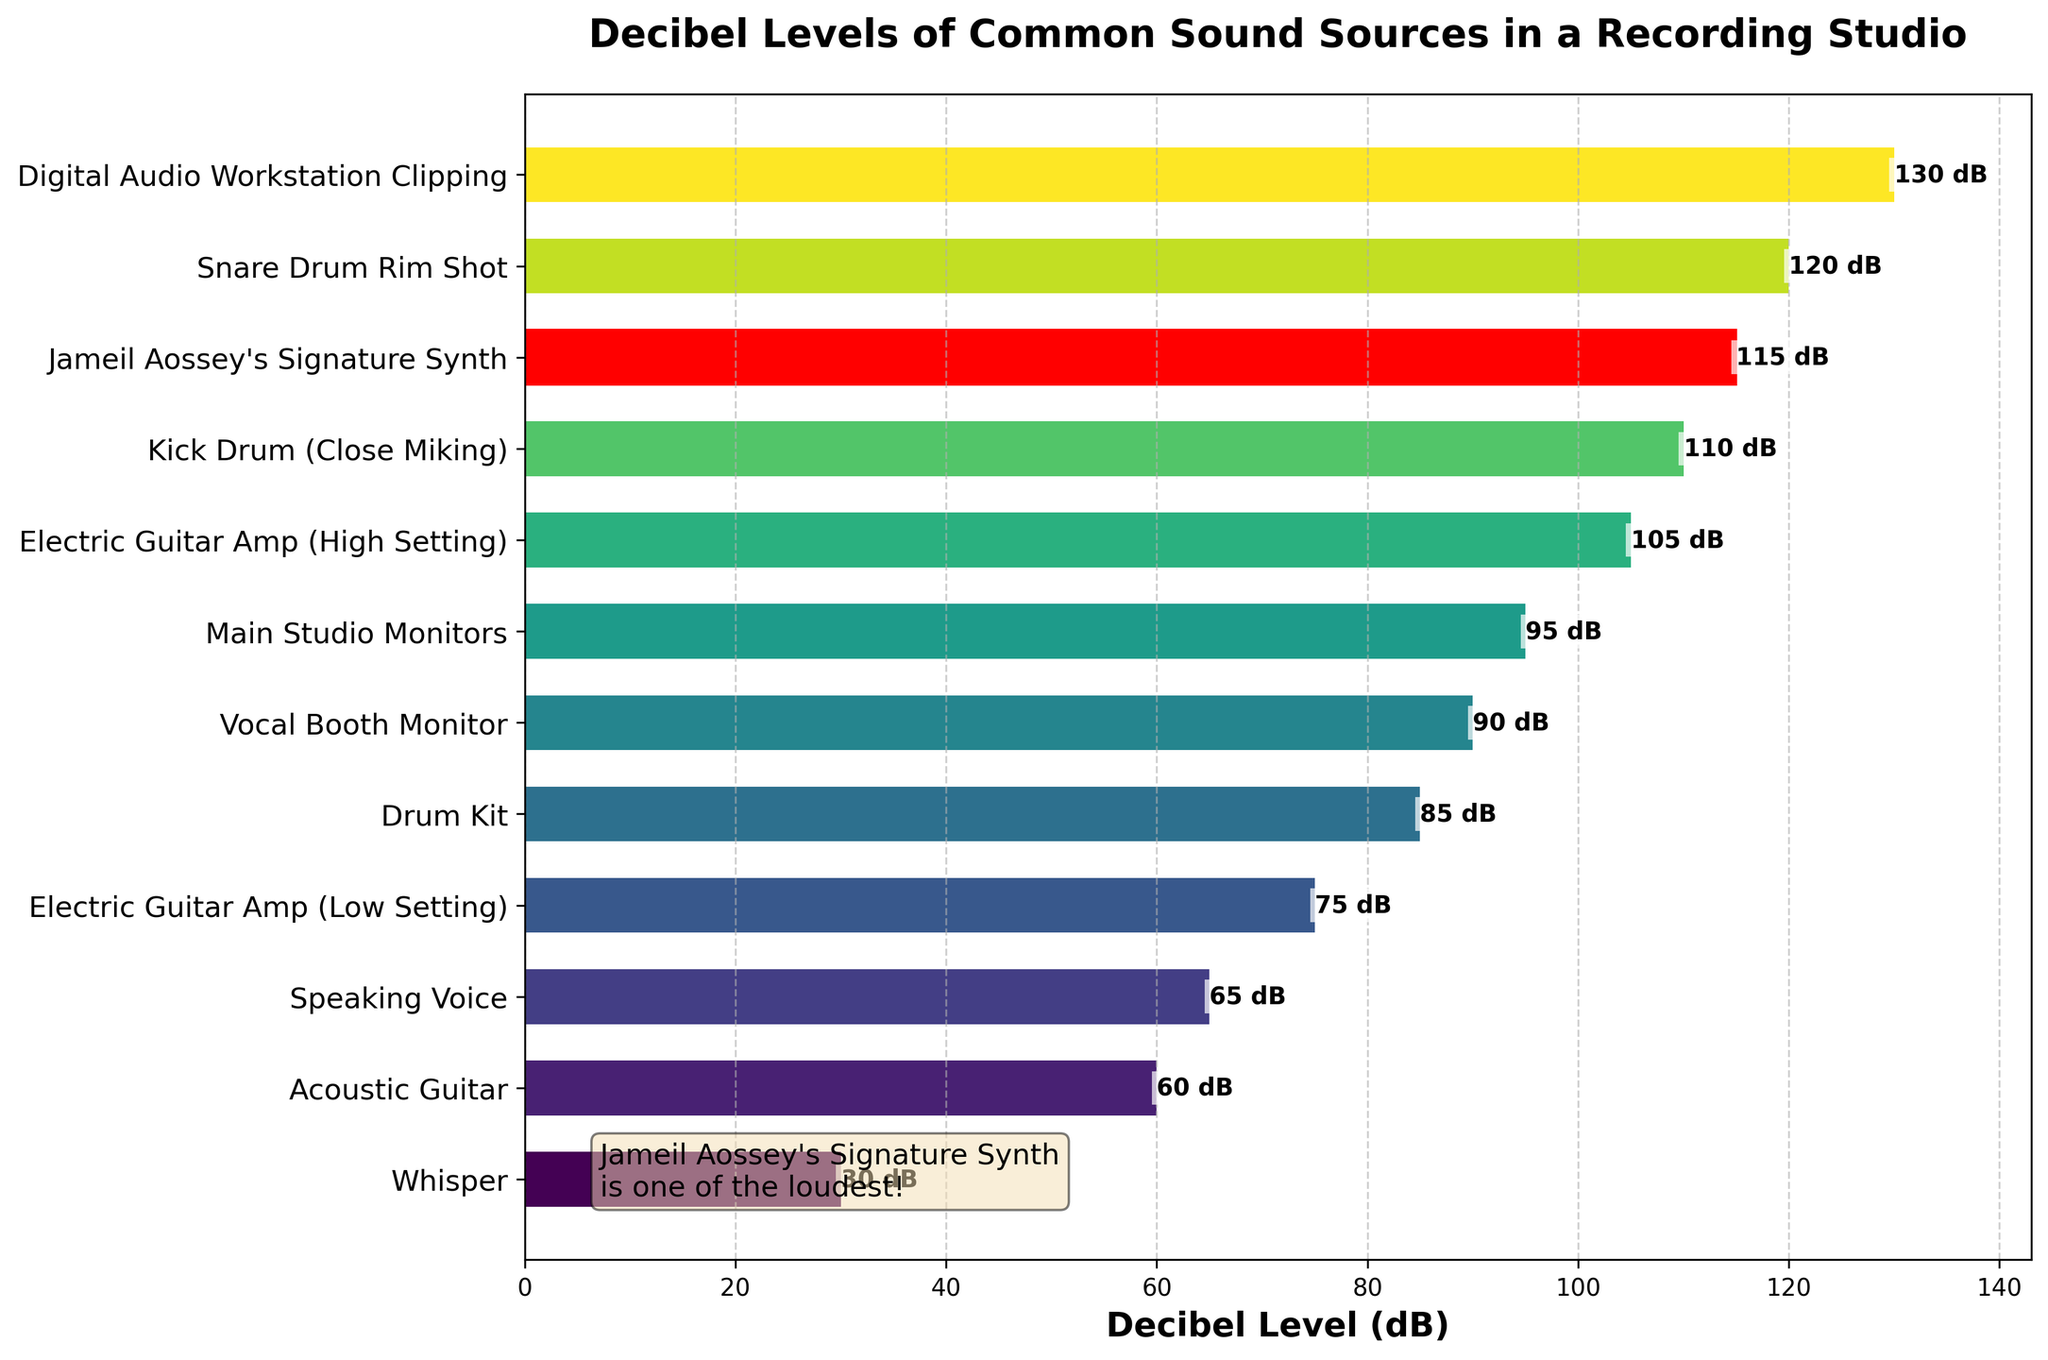what is the loudest sound source in the figure? The loudest sound source can be identified by looking at the bar with the highest decibel level. The highest bar reaches 130 dB, which belongs to Digital Audio Workstation Clipping.
Answer: Digital Audio Workstation Clipping how much louder is Jameil Aossey's Signature Synth compared to a Drum Kit? The decibel level of Jameil Aossey's Signature Synth is 115 dB, and the decibel level of a Drum Kit is 85 dB. Subtract 85 from 115: 115 - 85 = 30.
Answer: 30 dB which sound sources are louder than 100 dB? Examine the bars that reach higher than the 100 dB mark. The sound sources louder than 100 dB are Electric Guitar Amp (High Setting), Kick Drum (Close Miking), Jameil Aossey's Signature Synth, Snare Drum Rim Shot, and Digital Audio Workstation Clipping.
Answer: Electric Guitar Amp (High Setting), Kick Drum (Close Miking), Jameil Aossey's Signature Synth, Snare Drum Rim Shot, Digital Audio Workstation Clipping what is the decibel difference between a Whisper and Speaking Voice? The decibel level of a Whisper is 30 dB, and the decibel level of a Speaking Voice is 65 dB. Subtract 30 from 65: 65 - 30 = 35.
Answer: 35 dB are Acoustic Guitar and Speaking Voice similar in decibel levels? Look at the two bars for Acoustic Guitar and Speaking Voice. The Acoustic Guitar is at 60 dB, and the Speaking Voice is at 65 dB. The difference is 65 - 60 = 5 dB, which indicates they are close in decibel levels.
Answer: Yes, they are similar (5 dB difference) what visual feature highlights Jameil Aossey's Signature Synth? Jameil Aossey's Signature Synth is visually highlighted by its color. Unlike the other bars, it is colored red.
Answer: The bar is colored red 